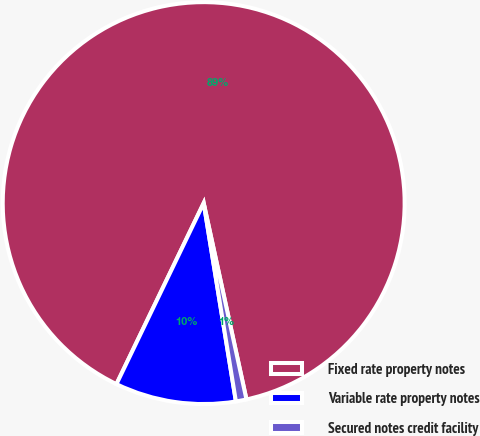<chart> <loc_0><loc_0><loc_500><loc_500><pie_chart><fcel>Fixed rate property notes<fcel>Variable rate property notes<fcel>Secured notes credit facility<nl><fcel>89.43%<fcel>9.71%<fcel>0.85%<nl></chart> 